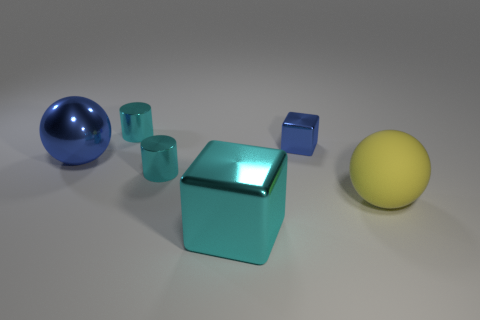Is the number of large yellow rubber balls in front of the big cyan block less than the number of green rubber cubes? Upon inspecting the image, we can clearly see that there is only one large yellow rubber ball in front of the big cyan block. Meanwhile, there are two smaller green rubber cubes off to the side. Therefore, considering the sizes and positions, the number of large yellow rubber balls in front of the cyan block is indeed less than the number of green rubber cubes. 